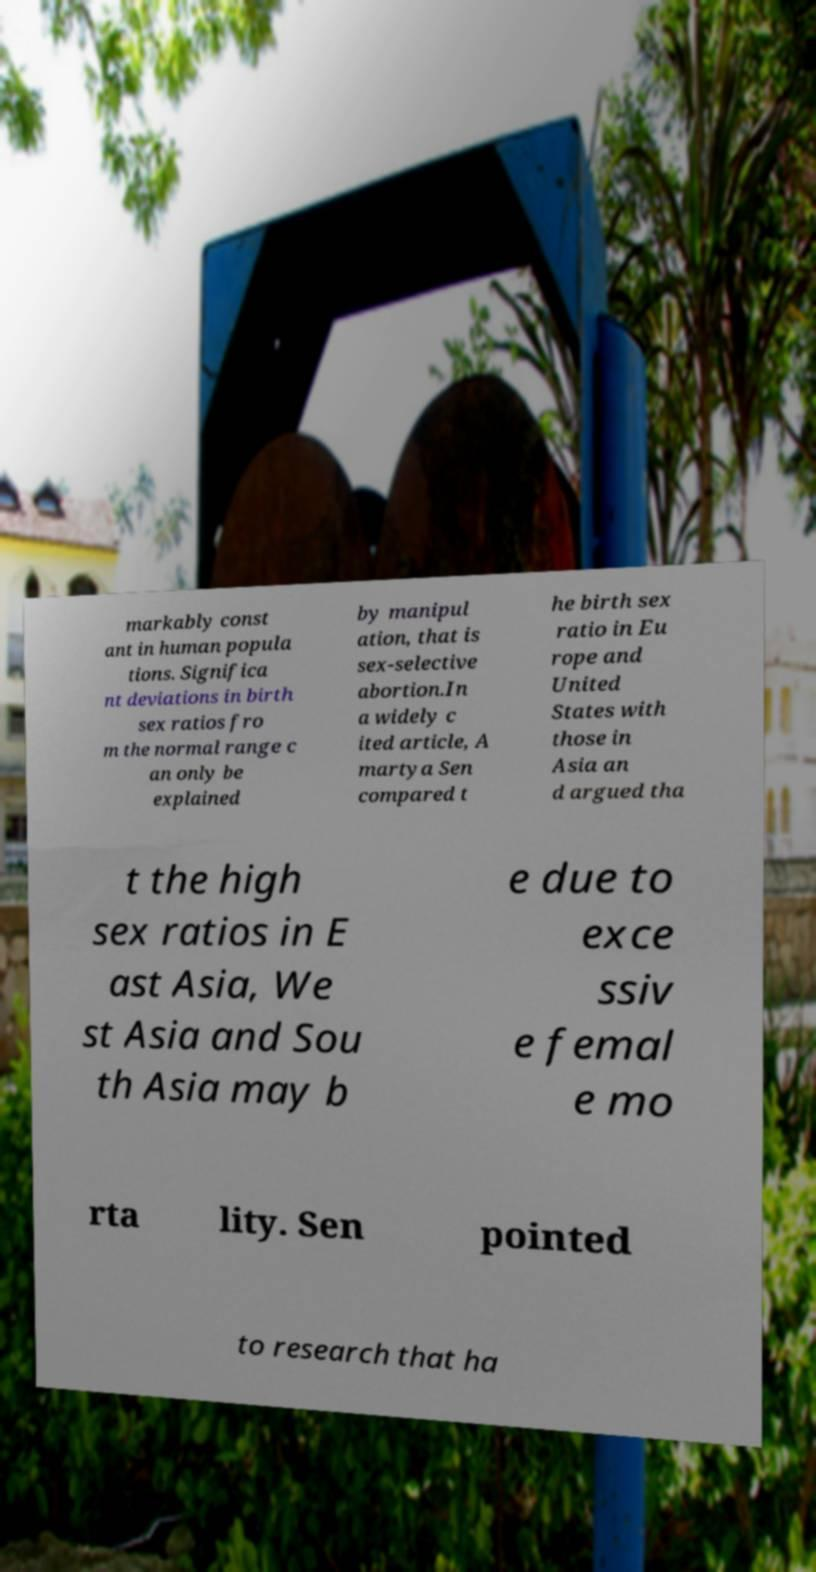What messages or text are displayed in this image? I need them in a readable, typed format. markably const ant in human popula tions. Significa nt deviations in birth sex ratios fro m the normal range c an only be explained by manipul ation, that is sex-selective abortion.In a widely c ited article, A martya Sen compared t he birth sex ratio in Eu rope and United States with those in Asia an d argued tha t the high sex ratios in E ast Asia, We st Asia and Sou th Asia may b e due to exce ssiv e femal e mo rta lity. Sen pointed to research that ha 